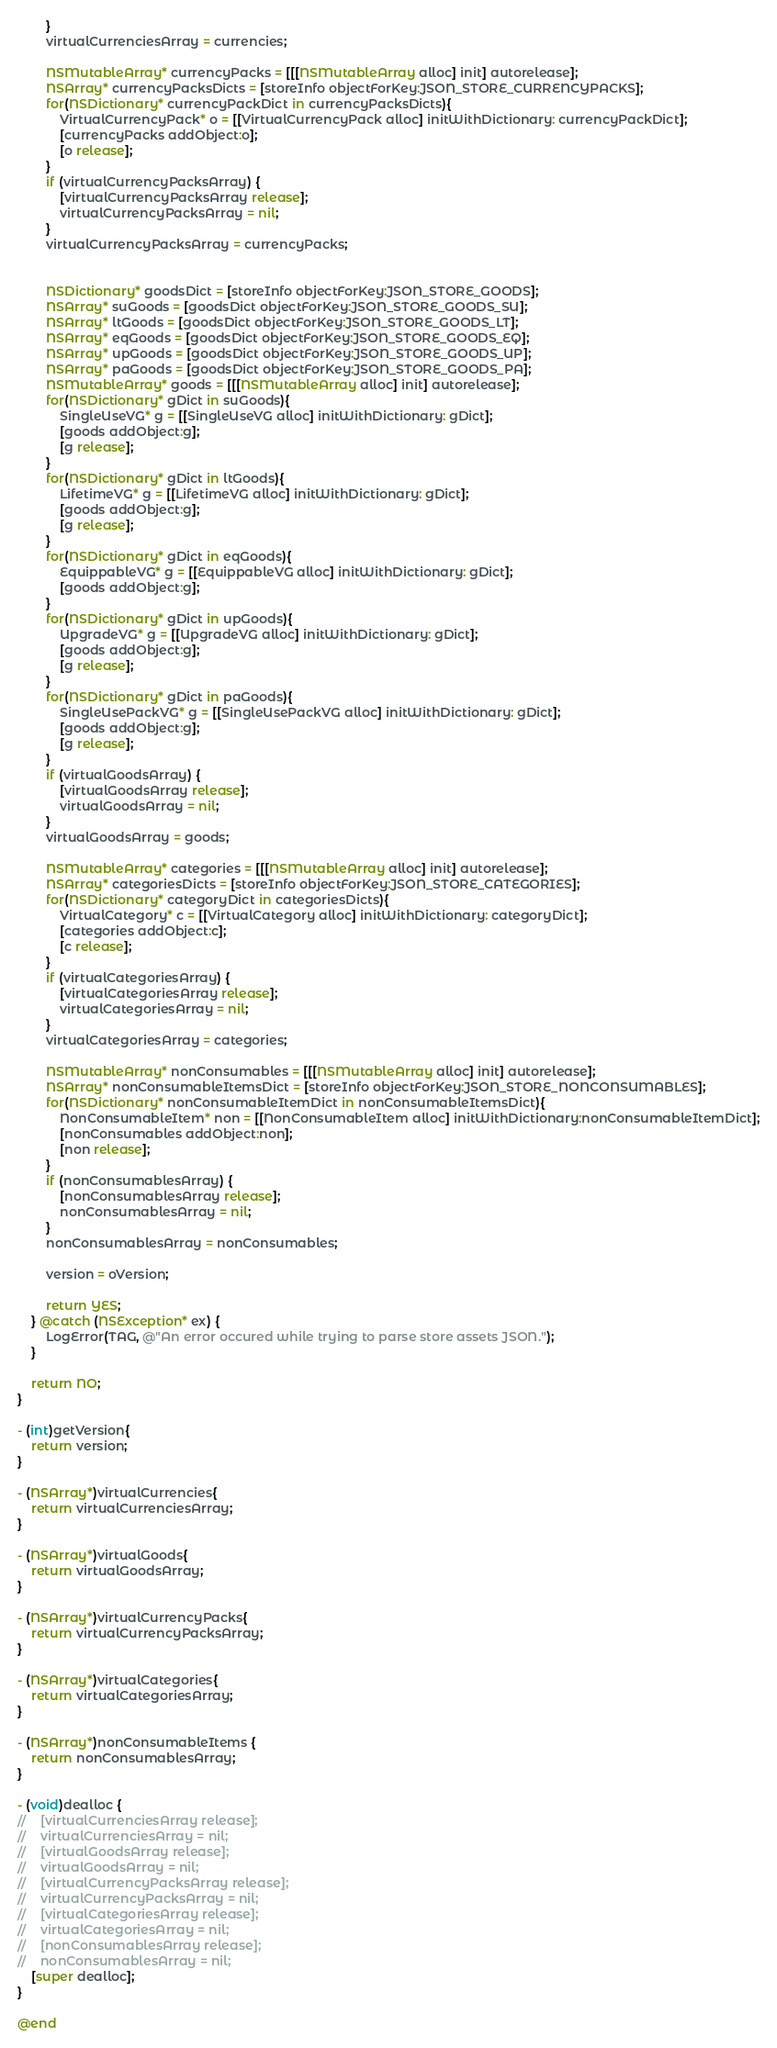Convert code to text. <code><loc_0><loc_0><loc_500><loc_500><_ObjectiveC_>        }
        virtualCurrenciesArray = currencies;
        
        NSMutableArray* currencyPacks = [[[NSMutableArray alloc] init] autorelease];
        NSArray* currencyPacksDicts = [storeInfo objectForKey:JSON_STORE_CURRENCYPACKS];
        for(NSDictionary* currencyPackDict in currencyPacksDicts){
            VirtualCurrencyPack* o = [[VirtualCurrencyPack alloc] initWithDictionary: currencyPackDict];
            [currencyPacks addObject:o];
            [o release];
        }
        if (virtualCurrencyPacksArray) {
            [virtualCurrencyPacksArray release];
            virtualCurrencyPacksArray = nil;
        }
        virtualCurrencyPacksArray = currencyPacks;
        
        
        NSDictionary* goodsDict = [storeInfo objectForKey:JSON_STORE_GOODS];
        NSArray* suGoods = [goodsDict objectForKey:JSON_STORE_GOODS_SU];
        NSArray* ltGoods = [goodsDict objectForKey:JSON_STORE_GOODS_LT];
        NSArray* eqGoods = [goodsDict objectForKey:JSON_STORE_GOODS_EQ];
        NSArray* upGoods = [goodsDict objectForKey:JSON_STORE_GOODS_UP];
        NSArray* paGoods = [goodsDict objectForKey:JSON_STORE_GOODS_PA];
        NSMutableArray* goods = [[[NSMutableArray alloc] init] autorelease];
        for(NSDictionary* gDict in suGoods){
            SingleUseVG* g = [[SingleUseVG alloc] initWithDictionary: gDict];
			[goods addObject:g];
            [g release];
        }
        for(NSDictionary* gDict in ltGoods){
            LifetimeVG* g = [[LifetimeVG alloc] initWithDictionary: gDict];
			[goods addObject:g];
            [g release];
        }
        for(NSDictionary* gDict in eqGoods){
            EquippableVG* g = [[EquippableVG alloc] initWithDictionary: gDict];
			[goods addObject:g];
        }
        for(NSDictionary* gDict in upGoods){
            UpgradeVG* g = [[UpgradeVG alloc] initWithDictionary: gDict];
			[goods addObject:g];
            [g release];
        }
        for(NSDictionary* gDict in paGoods){
            SingleUsePackVG* g = [[SingleUsePackVG alloc] initWithDictionary: gDict];
			[goods addObject:g];
            [g release];
        }
        if (virtualGoodsArray) {
            [virtualGoodsArray release];
            virtualGoodsArray = nil;
        }
        virtualGoodsArray = goods;
        
        NSMutableArray* categories = [[[NSMutableArray alloc] init] autorelease];
        NSArray* categoriesDicts = [storeInfo objectForKey:JSON_STORE_CATEGORIES];
        for(NSDictionary* categoryDict in categoriesDicts){
            VirtualCategory* c = [[VirtualCategory alloc] initWithDictionary: categoryDict];
            [categories addObject:c];
            [c release];
        }
        if (virtualCategoriesArray) {
            [virtualCategoriesArray release];
            virtualCategoriesArray = nil;
        }
        virtualCategoriesArray = categories;
        
        NSMutableArray* nonConsumables = [[[NSMutableArray alloc] init] autorelease];
        NSArray* nonConsumableItemsDict = [storeInfo objectForKey:JSON_STORE_NONCONSUMABLES];
        for(NSDictionary* nonConsumableItemDict in nonConsumableItemsDict){
            NonConsumableItem* non = [[NonConsumableItem alloc] initWithDictionary:nonConsumableItemDict];
            [nonConsumables addObject:non];
            [non release];
        }
        if (nonConsumablesArray) {
            [nonConsumablesArray release];
            nonConsumablesArray = nil;
        }
        nonConsumablesArray = nonConsumables;
        
        version = oVersion;
        
        return YES;
    } @catch (NSException* ex) {
        LogError(TAG, @"An error occured while trying to parse store assets JSON.");
    }
    
    return NO;
}

- (int)getVersion{
	return version;
}

- (NSArray*)virtualCurrencies{
    return virtualCurrenciesArray;
}

- (NSArray*)virtualGoods{
    return virtualGoodsArray;
}

- (NSArray*)virtualCurrencyPacks{
    return virtualCurrencyPacksArray;
}

- (NSArray*)virtualCategories{
    return virtualCategoriesArray;
}

- (NSArray*)nonConsumableItems {
    return nonConsumablesArray;
}

- (void)dealloc {
//    [virtualCurrenciesArray release];
//    virtualCurrenciesArray = nil;
//    [virtualGoodsArray release];
//    virtualGoodsArray = nil;
//    [virtualCurrencyPacksArray release];
//    virtualCurrencyPacksArray = nil;
//    [virtualCategoriesArray release];
//    virtualCategoriesArray = nil;
//    [nonConsumablesArray release];
//    nonConsumablesArray = nil;
    [super dealloc];
}

@end
</code> 